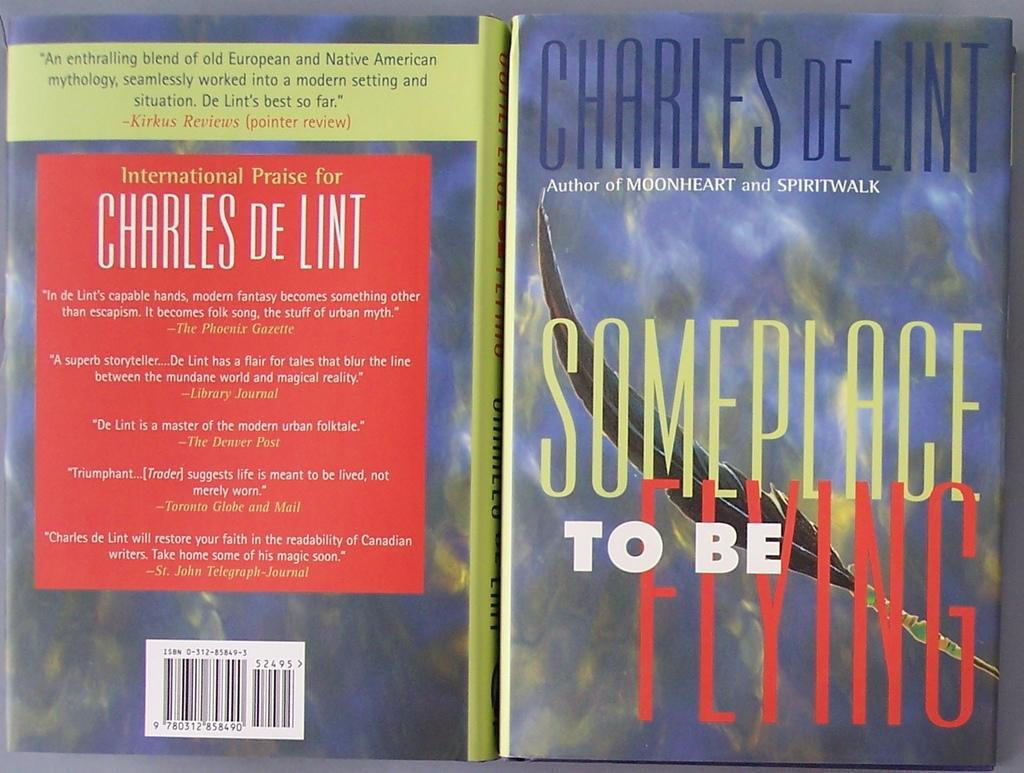Provide a one-sentence caption for the provided image. Book cover and back by Charles DeLint titled someplace to be flying. 